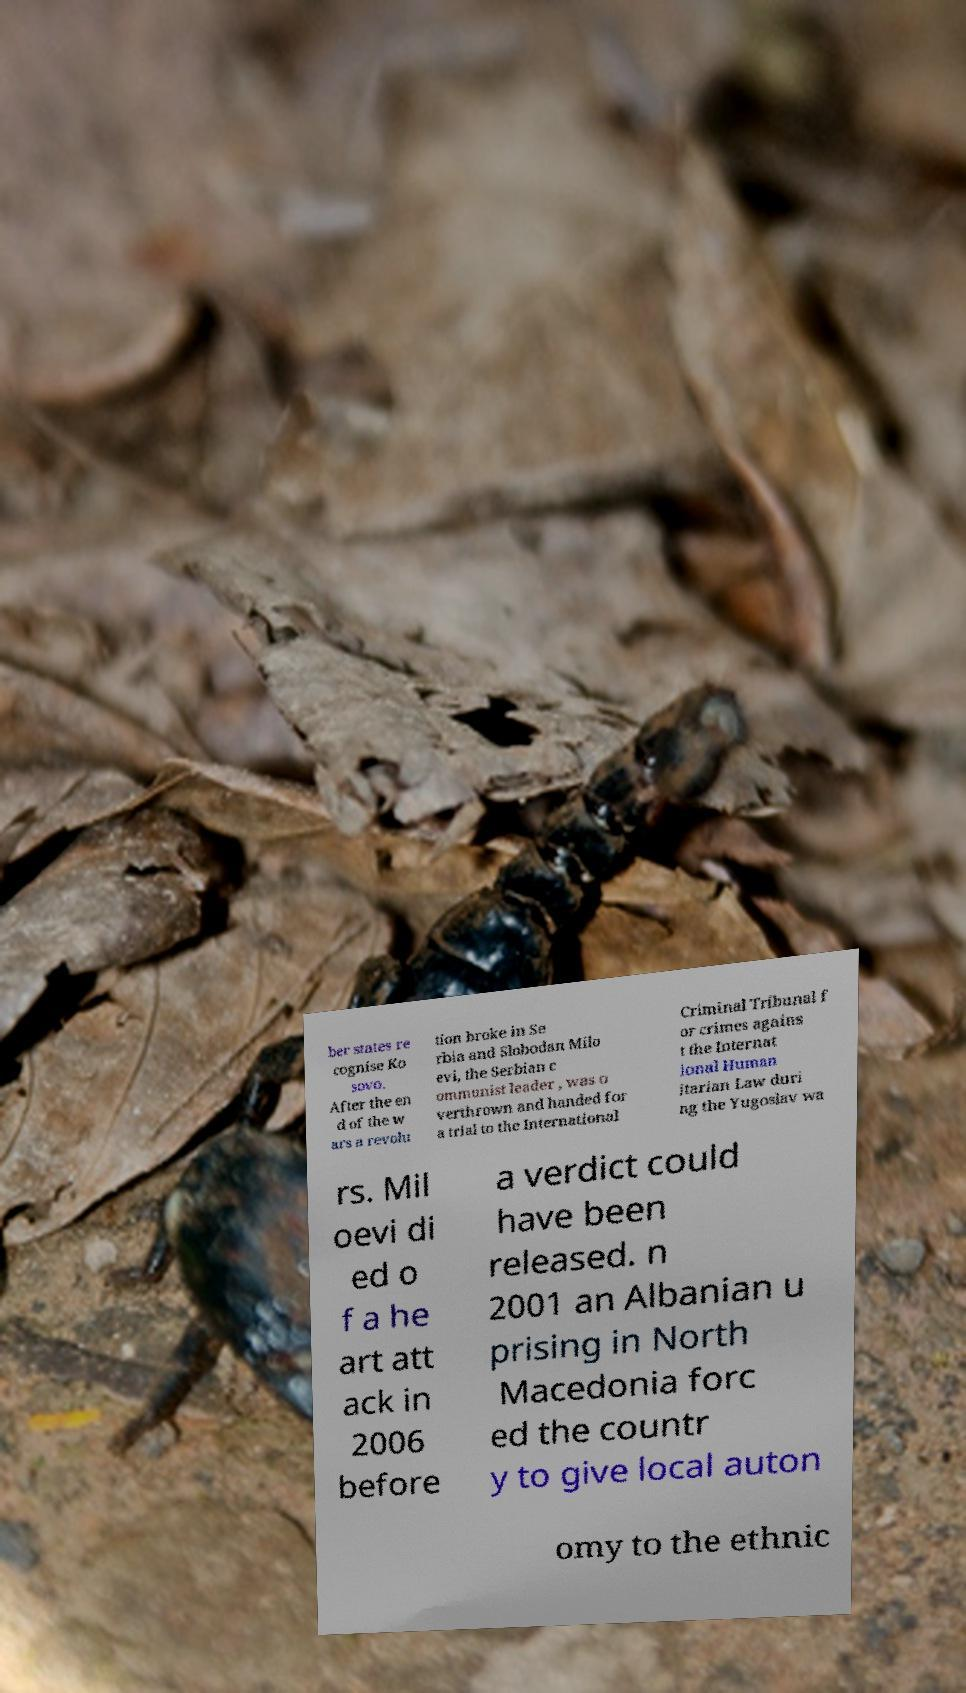There's text embedded in this image that I need extracted. Can you transcribe it verbatim? ber states re cognise Ko sovo. After the en d of the w ars a revolu tion broke in Se rbia and Slobodan Milo evi, the Serbian c ommunist leader , was o verthrown and handed for a trial to the International Criminal Tribunal f or crimes agains t the Internat ional Human itarian Law duri ng the Yugoslav wa rs. Mil oevi di ed o f a he art att ack in 2006 before a verdict could have been released. n 2001 an Albanian u prising in North Macedonia forc ed the countr y to give local auton omy to the ethnic 